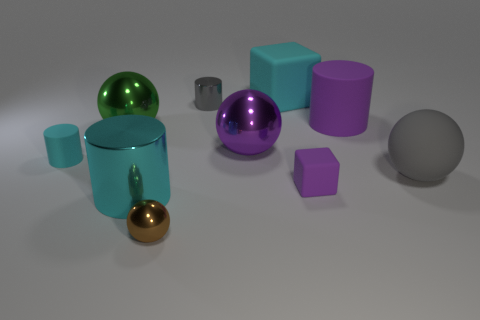What number of balls are on the left side of the brown metal object and to the right of the large cyan cube?
Offer a very short reply. 0. What material is the small object in front of the shiny cylinder in front of the green shiny object?
Your answer should be very brief. Metal. What material is the other object that is the same shape as the tiny purple rubber object?
Give a very brief answer. Rubber. Is there a big purple sphere?
Provide a short and direct response. Yes. The other small object that is made of the same material as the small purple thing is what shape?
Provide a short and direct response. Cylinder. There is a big cyan object that is to the left of the brown thing; what is its material?
Ensure brevity in your answer.  Metal. There is a tiny shiny object behind the tiny cyan rubber object; is its color the same as the large shiny cylinder?
Give a very brief answer. No. What size is the block that is behind the small rubber object that is in front of the gray rubber thing?
Provide a succinct answer. Large. Is the number of large cubes that are left of the large cyan shiny cylinder greater than the number of brown things?
Give a very brief answer. No. Are there the same number of blue cylinders and big gray balls?
Ensure brevity in your answer.  No. 